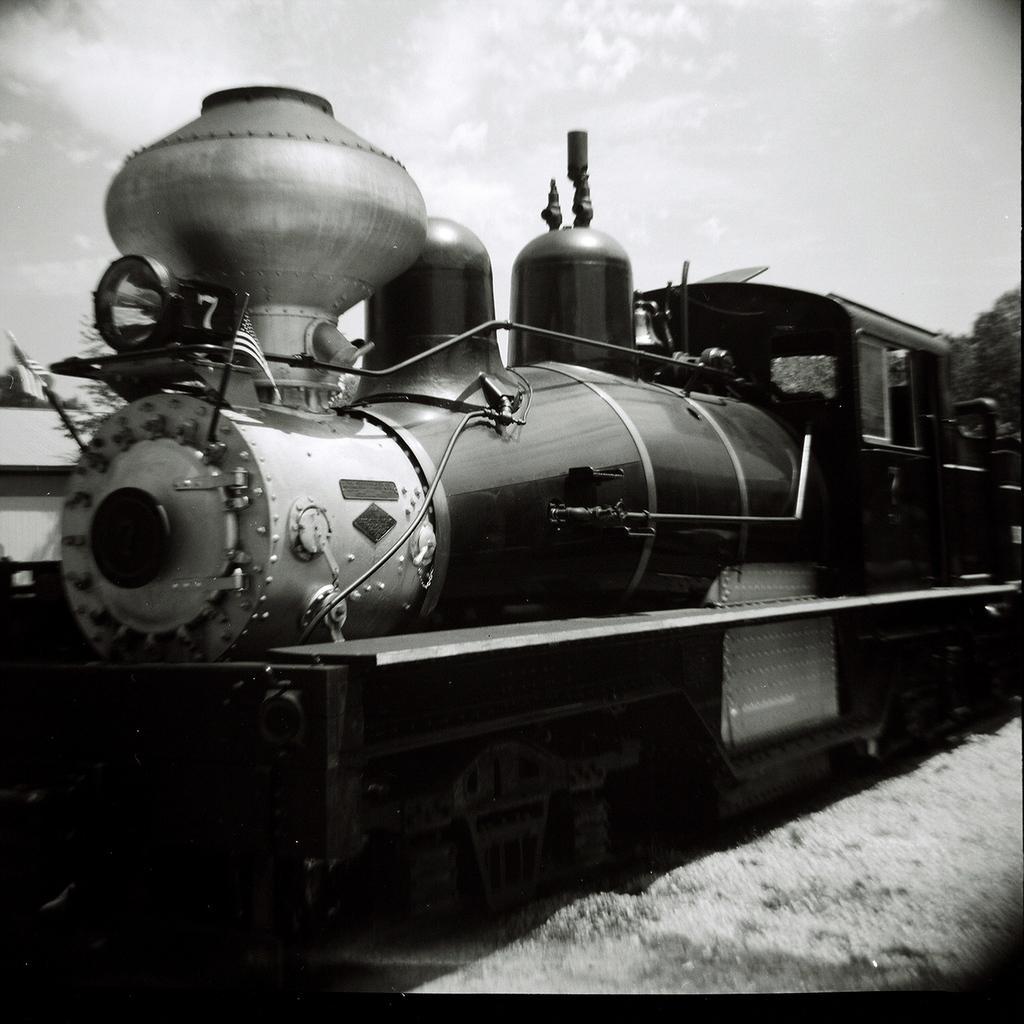Describe this image in one or two sentences. This is a black and white image. In this image I can see a train. At the bottom, I can see the ground. At the top of the image I can see the sky. 